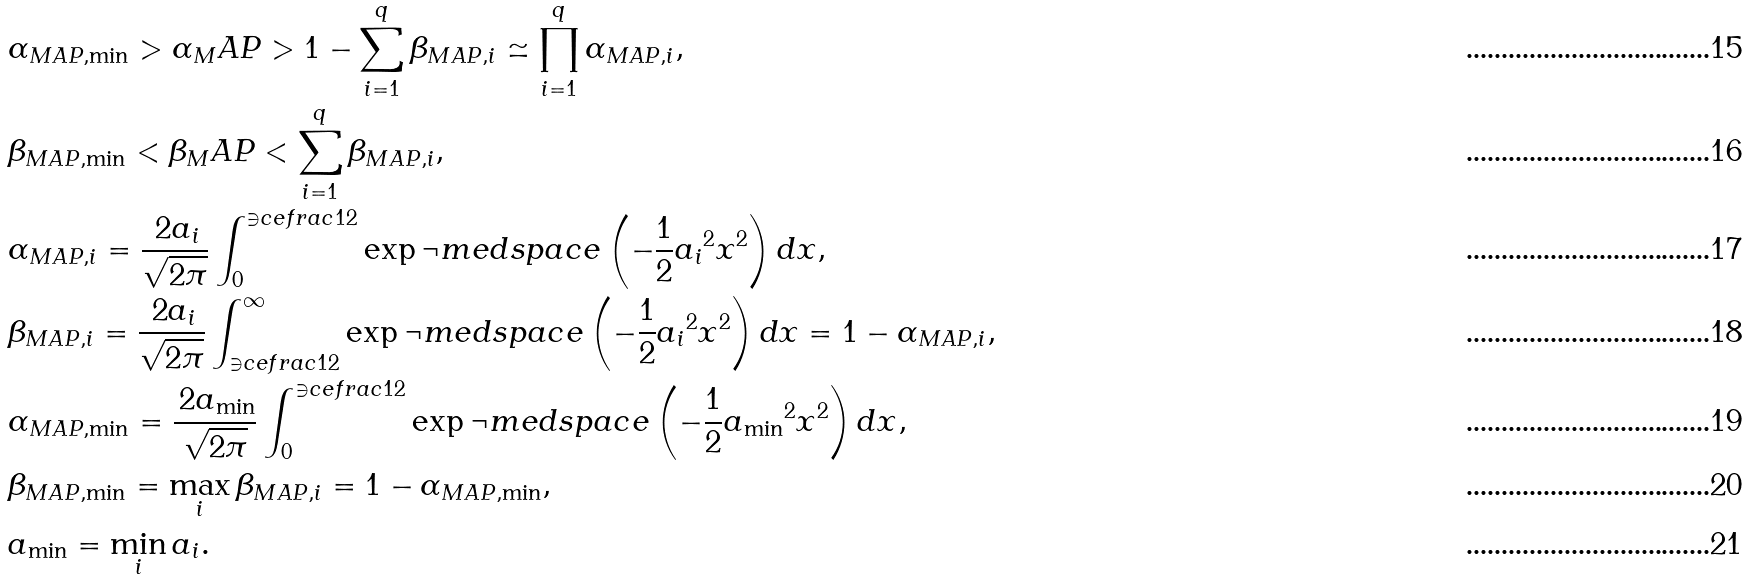<formula> <loc_0><loc_0><loc_500><loc_500>& \alpha _ { M A P , \min } > \alpha _ { M } A P > 1 - \sum _ { i = 1 } ^ { q } \beta _ { M A P , i } \simeq \prod _ { i = 1 } ^ { q } \alpha _ { M A P , i } , \\ & \beta _ { M A P , \min } < \beta _ { M } A P < \sum _ { i = 1 } ^ { q } \beta _ { M A P , i } , \\ & \alpha _ { M A P , i } = \frac { \, 2 a _ { i } } { \sqrt { 2 \pi } } \int _ { 0 } ^ { \ni c e f r a c { 1 } { 2 } } \exp \neg m e d s p a c e \left ( - \frac { 1 } { 2 } { a _ { i } } ^ { 2 } x ^ { 2 } \right ) d x , \\ & \beta _ { M A P , i } = \frac { \, 2 a _ { i } } { \sqrt { 2 \pi } } \int _ { \ni c e f r a c { 1 } { 2 } } ^ { \infty } \exp \neg m e d s p a c e \left ( - \frac { 1 } { 2 } { a _ { i } } ^ { 2 } x ^ { 2 } \right ) d x = 1 - \alpha _ { M A P , i } , \\ & \alpha _ { M A P , \min } = \frac { \, 2 a _ { \min } } { \sqrt { 2 \pi } } \int _ { 0 } ^ { \ni c e f r a c { 1 } { 2 } } \exp \neg m e d s p a c e \left ( - \frac { 1 } { 2 } { a _ { \min } } ^ { 2 } x ^ { 2 } \right ) d x , \\ & \beta _ { M A P , \min } = \max _ { i } \beta _ { M A P , i } = 1 - \alpha _ { M A P , \min } , \\ & a _ { \min } = \min _ { i } a _ { i } .</formula> 